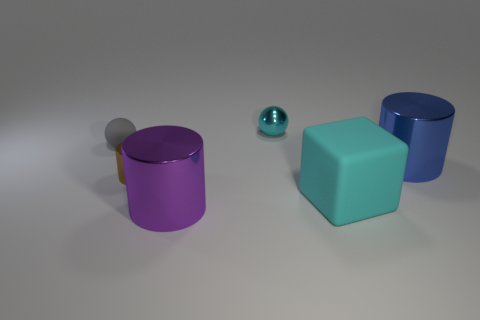Add 3 large shiny balls. How many objects exist? 9 Subtract all cubes. How many objects are left? 5 Subtract all small green metal cylinders. Subtract all large blue cylinders. How many objects are left? 5 Add 2 small cyan things. How many small cyan things are left? 3 Add 3 tiny gray things. How many tiny gray things exist? 4 Subtract 0 gray blocks. How many objects are left? 6 